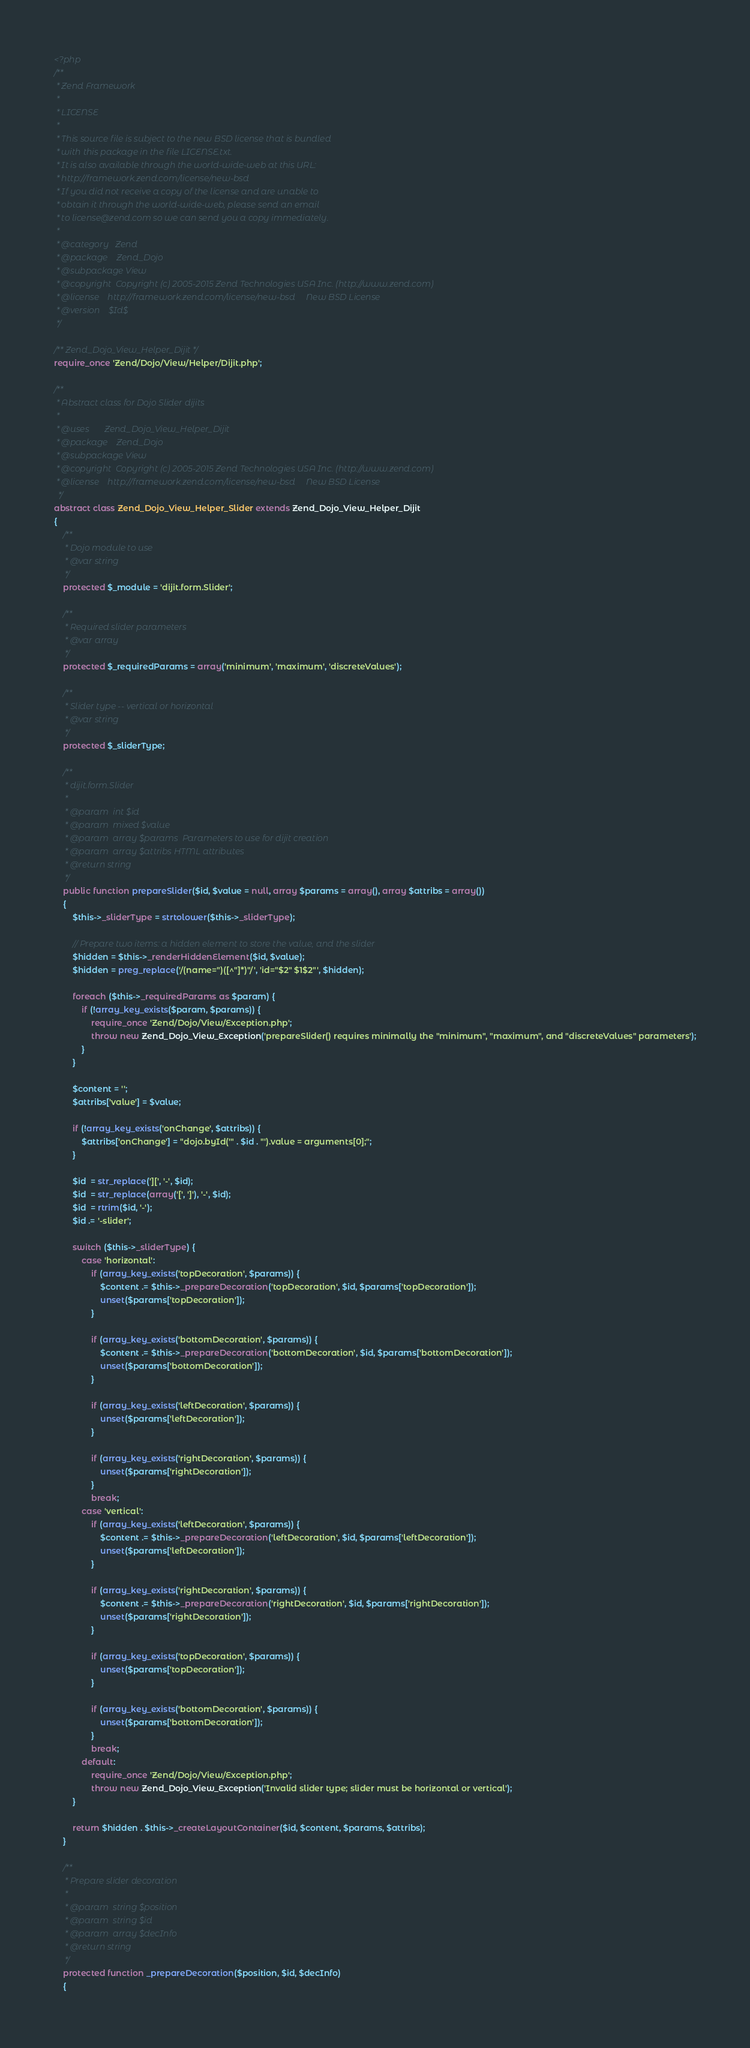<code> <loc_0><loc_0><loc_500><loc_500><_PHP_><?php
/**
 * Zend Framework
 *
 * LICENSE
 *
 * This source file is subject to the new BSD license that is bundled
 * with this package in the file LICENSE.txt.
 * It is also available through the world-wide-web at this URL:
 * http://framework.zend.com/license/new-bsd
 * If you did not receive a copy of the license and are unable to
 * obtain it through the world-wide-web, please send an email
 * to license@zend.com so we can send you a copy immediately.
 *
 * @category   Zend
 * @package    Zend_Dojo
 * @subpackage View
 * @copyright  Copyright (c) 2005-2015 Zend Technologies USA Inc. (http://www.zend.com)
 * @license    http://framework.zend.com/license/new-bsd     New BSD License
 * @version    $Id$
 */

/** Zend_Dojo_View_Helper_Dijit */
require_once 'Zend/Dojo/View/Helper/Dijit.php';

/**
 * Abstract class for Dojo Slider dijits
 *
 * @uses       Zend_Dojo_View_Helper_Dijit
 * @package    Zend_Dojo
 * @subpackage View
 * @copyright  Copyright (c) 2005-2015 Zend Technologies USA Inc. (http://www.zend.com)
 * @license    http://framework.zend.com/license/new-bsd     New BSD License
  */
abstract class Zend_Dojo_View_Helper_Slider extends Zend_Dojo_View_Helper_Dijit
{
    /**
     * Dojo module to use
     * @var string
     */
    protected $_module = 'dijit.form.Slider';

    /**
     * Required slider parameters
     * @var array
     */
    protected $_requiredParams = array('minimum', 'maximum', 'discreteValues');

    /**
     * Slider type -- vertical or horizontal
     * @var string
     */
    protected $_sliderType;

    /**
     * dijit.form.Slider
     *
     * @param  int $id
     * @param  mixed $value
     * @param  array $params  Parameters to use for dijit creation
     * @param  array $attribs HTML attributes
     * @return string
     */
    public function prepareSlider($id, $value = null, array $params = array(), array $attribs = array())
    {
        $this->_sliderType = strtolower($this->_sliderType);

        // Prepare two items: a hidden element to store the value, and the slider
        $hidden = $this->_renderHiddenElement($id, $value);
        $hidden = preg_replace('/(name=")([^"]*)"/', 'id="$2" $1$2"', $hidden);

        foreach ($this->_requiredParams as $param) {
            if (!array_key_exists($param, $params)) {
                require_once 'Zend/Dojo/View/Exception.php';
                throw new Zend_Dojo_View_Exception('prepareSlider() requires minimally the "minimum", "maximum", and "discreteValues" parameters');
            }
        }

        $content = '';
        $attribs['value'] = $value;

        if (!array_key_exists('onChange', $attribs)) {
            $attribs['onChange'] = "dojo.byId('" . $id . "').value = arguments[0];";
        }

        $id  = str_replace('][', '-', $id);
        $id  = str_replace(array('[', ']'), '-', $id);
        $id  = rtrim($id, '-');
        $id .= '-slider';

        switch ($this->_sliderType) {
            case 'horizontal':
                if (array_key_exists('topDecoration', $params)) {
                    $content .= $this->_prepareDecoration('topDecoration', $id, $params['topDecoration']);
                    unset($params['topDecoration']);
                }

                if (array_key_exists('bottomDecoration', $params)) {
                    $content .= $this->_prepareDecoration('bottomDecoration', $id, $params['bottomDecoration']);
                    unset($params['bottomDecoration']);
                }

                if (array_key_exists('leftDecoration', $params)) {
                    unset($params['leftDecoration']);
                }

                if (array_key_exists('rightDecoration', $params)) {
                    unset($params['rightDecoration']);
                }
                break;
            case 'vertical':
                if (array_key_exists('leftDecoration', $params)) {
                    $content .= $this->_prepareDecoration('leftDecoration', $id, $params['leftDecoration']);
                    unset($params['leftDecoration']);
                }

                if (array_key_exists('rightDecoration', $params)) {
                    $content .= $this->_prepareDecoration('rightDecoration', $id, $params['rightDecoration']);
                    unset($params['rightDecoration']);
                }

                if (array_key_exists('topDecoration', $params)) {
                    unset($params['topDecoration']);
                }

                if (array_key_exists('bottomDecoration', $params)) {
                    unset($params['bottomDecoration']);
                }
                break;
            default:
                require_once 'Zend/Dojo/View/Exception.php';
                throw new Zend_Dojo_View_Exception('Invalid slider type; slider must be horizontal or vertical');
        }

        return $hidden . $this->_createLayoutContainer($id, $content, $params, $attribs);
    }

    /**
     * Prepare slider decoration
     *
     * @param  string $position
     * @param  string $id
     * @param  array $decInfo
     * @return string
     */
    protected function _prepareDecoration($position, $id, $decInfo)
    {</code> 